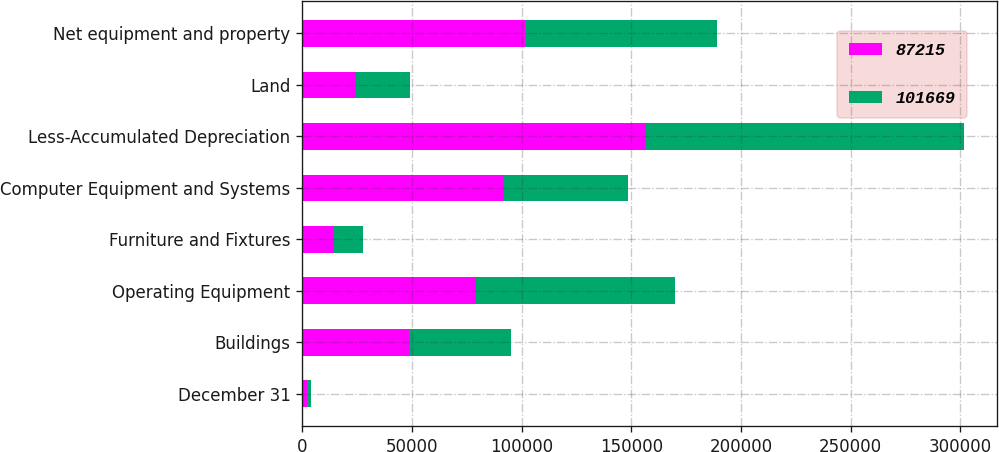Convert chart to OTSL. <chart><loc_0><loc_0><loc_500><loc_500><stacked_bar_chart><ecel><fcel>December 31<fcel>Buildings<fcel>Operating Equipment<fcel>Furniture and Fixtures<fcel>Computer Equipment and Systems<fcel>Less-Accumulated Depreciation<fcel>Land<fcel>Net equipment and property<nl><fcel>87215<fcel>2014<fcel>48440<fcel>79235<fcel>14303<fcel>92064<fcel>156940<fcel>24567<fcel>101669<nl><fcel>101669<fcel>2013<fcel>46574<fcel>90793<fcel>13477<fcel>56564<fcel>144877<fcel>24684<fcel>87215<nl></chart> 